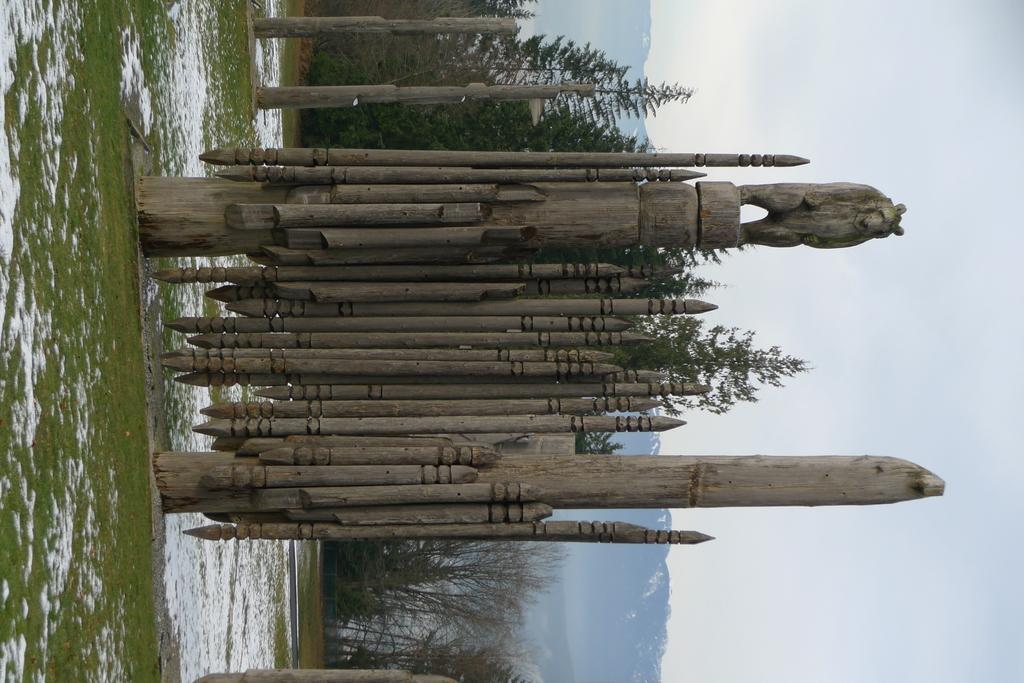Please provide a concise description of this image. In the center of the picture there is a wooden sculpture. On the left there are grass and snow. In the bottom there is snow. In the center of the background there are trees and mountains. Towards right it is sky, sky is cloudy. 